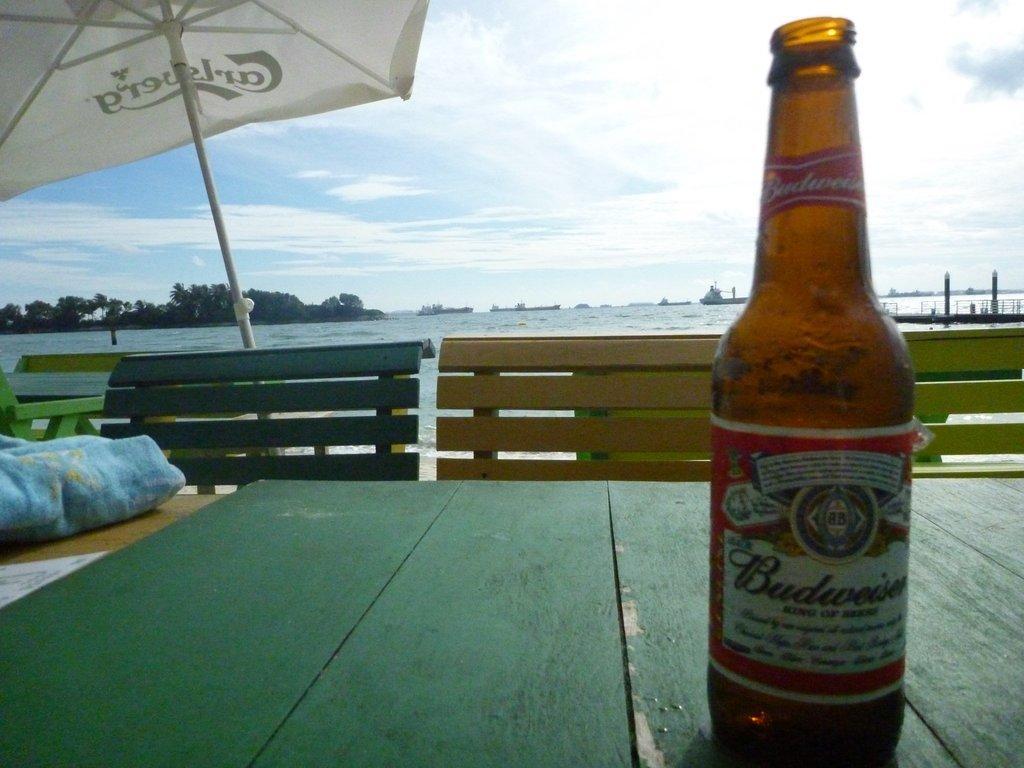Describe this image in one or two sentences. In the bottom of the image, there is a table on which liquor bottle is kept. Next to that benches are there and a umbrella is dig under the ground. In the background of the image, there is a sky white and blue in color. Below that there is a ocean. In the middle of the image left, there are trees. Next to that there are boats visible. This image is taken during day time. 